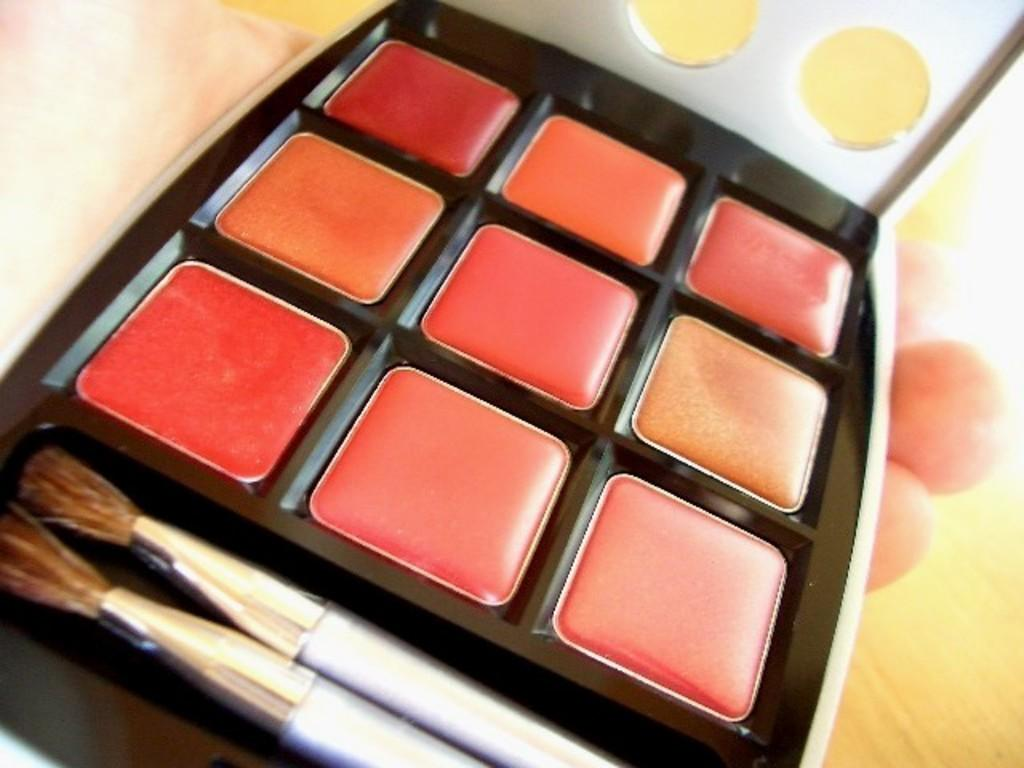What object is the main focus of the image? There is a makeup box in the image. What items are inside the makeup box? There are two brushes in the makeup box. Who is holding the makeup box in the image? The makeup box is being held by a person. What type of surface is visible in the image? The image shows a floor. Can you see a yak sleeping on the plate in the image? No, there is no yak or plate present in the image. 